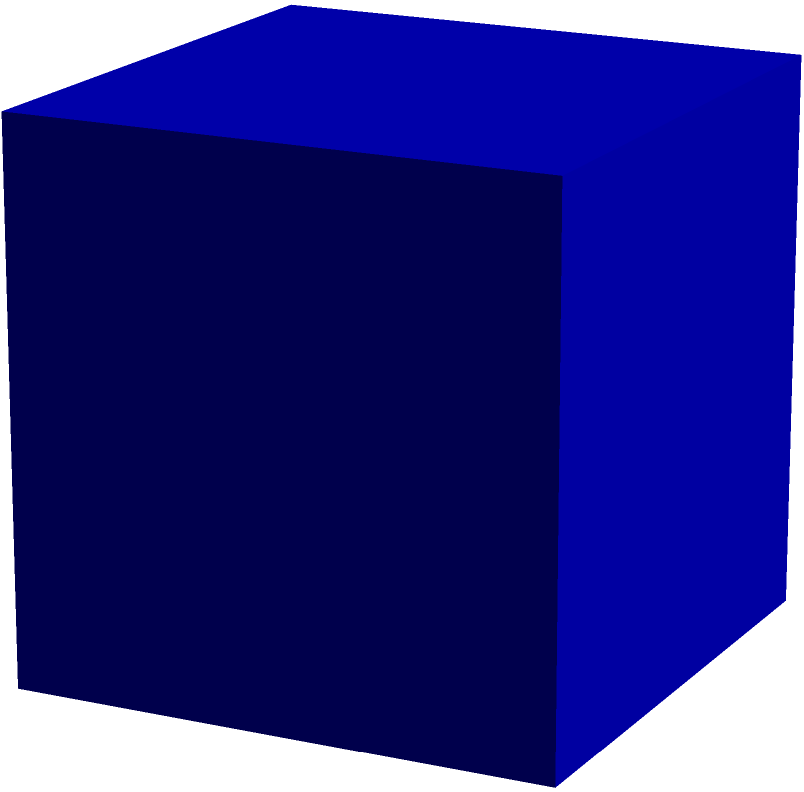You've acquired a rare cube-shaped retro gaming console for your collection. Each edge of the console measures 8 cm. If you want to create a custom protective case that covers the entire surface of the console, how much material (in square centimeters) would you need? Let's approach this step-by-step:

1) First, recall that a cube has 6 identical square faces.

2) The length of each edge is 8 cm, so each face is a square with side length 8 cm.

3) The area of one square face is:
   $A_{face} = s^2 = 8^2 = 64$ cm²

4) Since there are 6 identical faces, the total surface area is:
   $A_{total} = 6 \times A_{face}$

5) Substituting the value we found for $A_{face}$:
   $A_{total} = 6 \times 64 = 384$ cm²

Therefore, you would need 384 square centimeters of material to cover the entire surface of the cube-shaped retro gaming console.
Answer: 384 cm² 